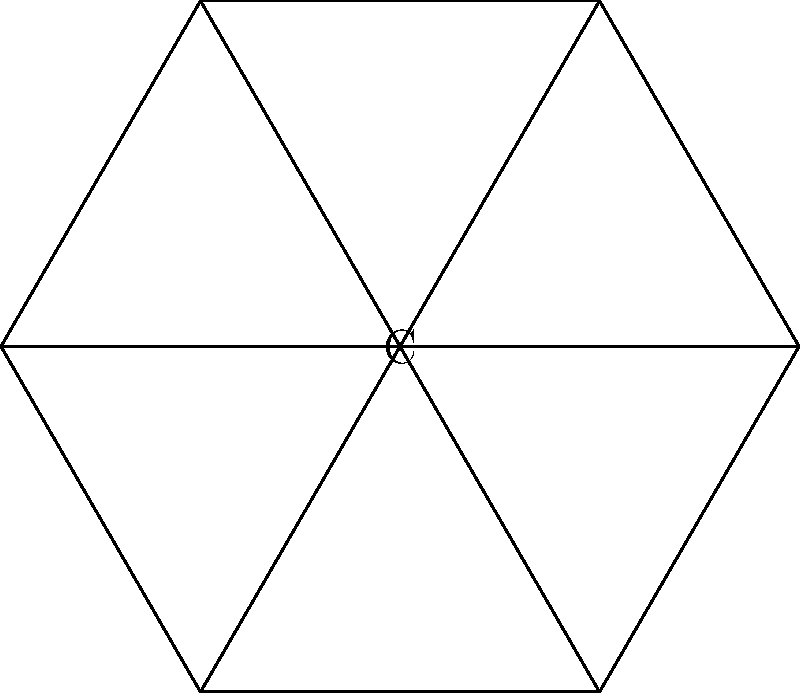Consider the classified document seal shown above, which represents a regular hexagon with its six lines of symmetry. What is the order of the symmetry group of this seal? To determine the order of the symmetry group, we need to count all the symmetries of the regular hexagon:

1. Rotational symmetries:
   - Identity (0° rotation)
   - 60° rotation
   - 120° rotation
   - 180° rotation
   - 240° rotation
   - 300° rotation
   Total rotational symmetries: 6

2. Reflection symmetries:
   - 6 lines of symmetry (as shown in the diagram)
   Total reflection symmetries: 6

3. Total number of symmetries:
   Rotational symmetries + Reflection symmetries = 6 + 6 = 12

Therefore, the order of the symmetry group is 12. This group is known as the dihedral group $D_6$ or $D_{12}$, depending on the notation used.
Answer: 12 